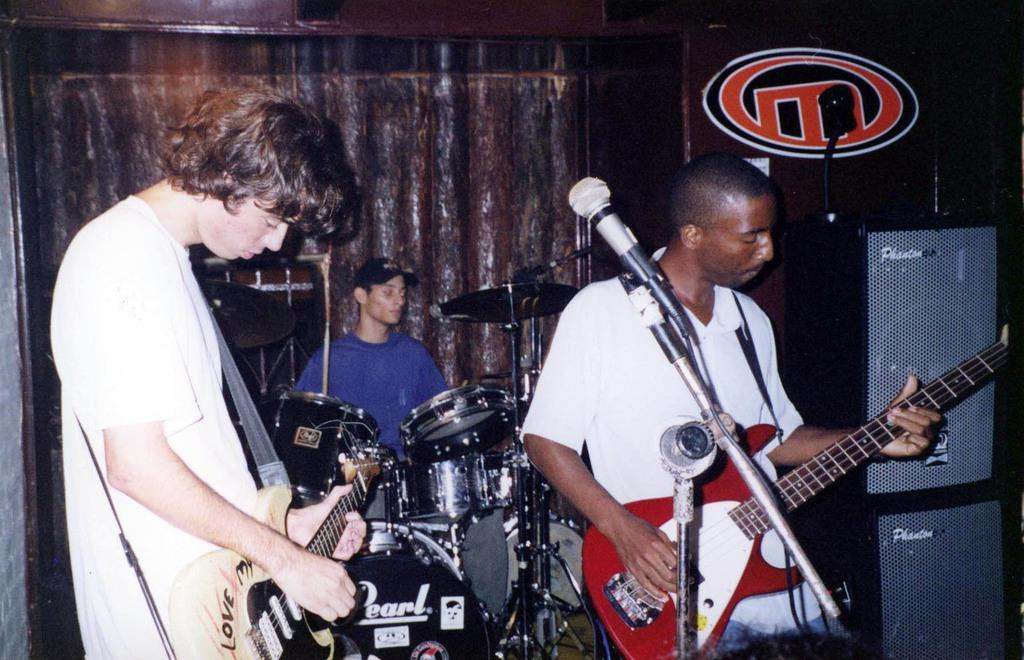What type of band is performing in the image? There is a rock band performing in the image. Where is the rock band performing? The rock band is performing on stage. What type of owl can be seen flying over the stage during the performance? There is no owl present in the image; it features a rock band performing on stage. How many men are visible in the image? The provided facts do not specify the number of men in the image, only that there is a rock band performing. 